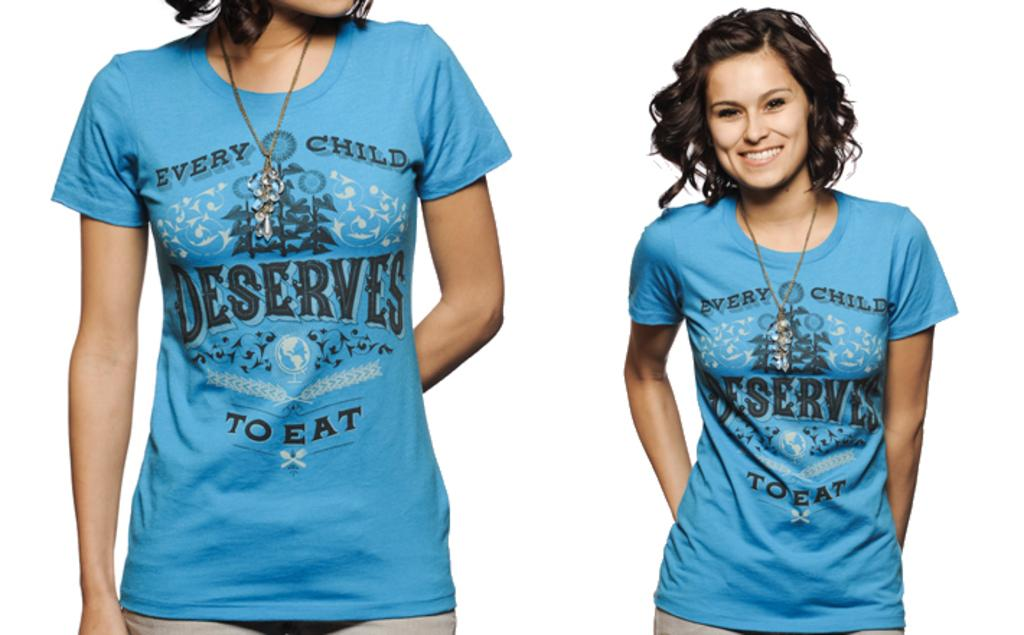<image>
Summarize the visual content of the image. A woman wearing a shirt that says every child deserves to eat is visible twice, with the left version of her zoomed in on the shirt. 